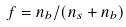<formula> <loc_0><loc_0><loc_500><loc_500>f = n _ { b } / ( n _ { s } + n _ { b } )</formula> 